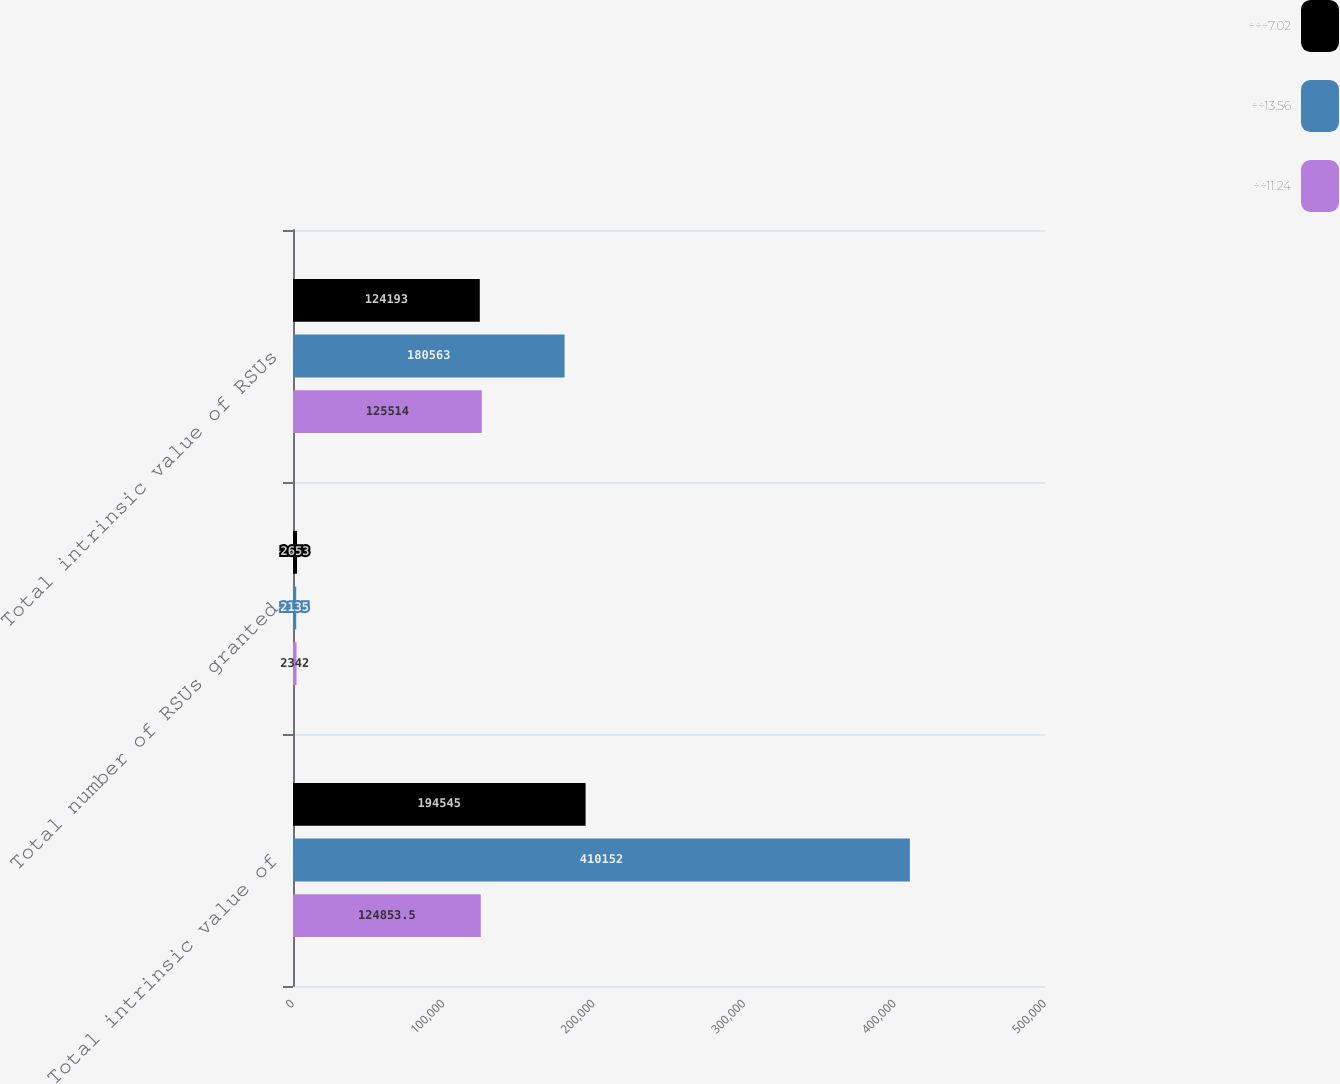Convert chart to OTSL. <chart><loc_0><loc_0><loc_500><loc_500><stacked_bar_chart><ecel><fcel>Total intrinsic value of<fcel>Total number of RSUs granted<fcel>Total intrinsic value of RSUs<nl><fcel>÷÷÷7.02<fcel>194545<fcel>2653<fcel>124193<nl><fcel>÷÷13.56<fcel>410152<fcel>2135<fcel>180563<nl><fcel>÷÷11.24<fcel>124854<fcel>2342<fcel>125514<nl></chart> 